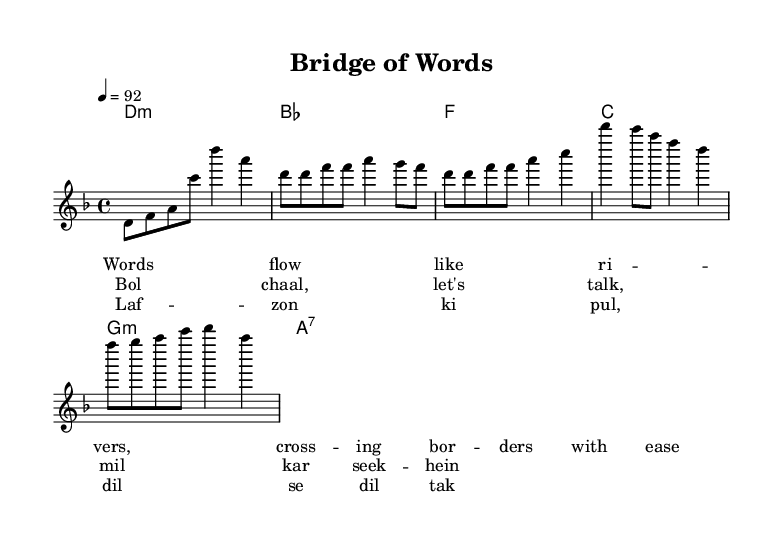What is the key signature of this music? The key signature is D minor, which has one flat (B flat).
Answer: D minor What is the time signature of this music? The time signature is four beats per measure, which is indicated by 4/4.
Answer: 4/4 What is the tempo marking for this piece? The tempo marking is set at a quarter note equals 92 beats per minute, indicating moderate speed.
Answer: 92 How many lines are present in the melody section? The melody section has a total of six lines comprising the notes and rests formatted in the score.
Answer: Six lines Which language is primarily used in the chorus? The chorus predominantly features lyrics in Urdu mixed with English.
Answer: Urdu In the first verse, what natural imagery is used in the lyrics? The lyrics describe words flowing like rivers, creating a natural image of fluid communication across cultures.
Answer: Rivers How does the structure of the piece reflect the genre of rap? The piece incorporates a rhythmic pattern with a lyrical blend of English and Urdu, typical of rap's cultural fusion elements.
Answer: Rhythmic pattern 